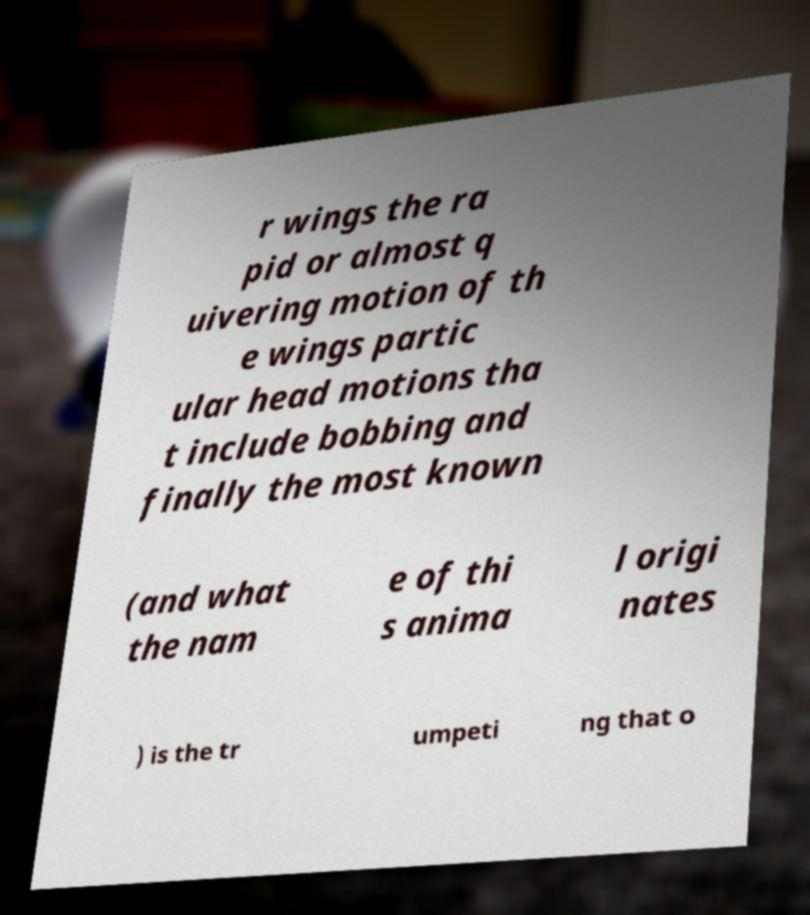For documentation purposes, I need the text within this image transcribed. Could you provide that? r wings the ra pid or almost q uivering motion of th e wings partic ular head motions tha t include bobbing and finally the most known (and what the nam e of thi s anima l origi nates ) is the tr umpeti ng that o 